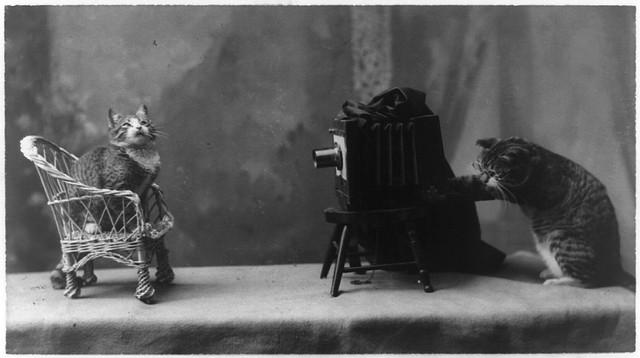What are the cats doing?
Give a very brief answer. Posing. Is this a color picture?
Keep it brief. No. How many props?
Write a very short answer. 2. 